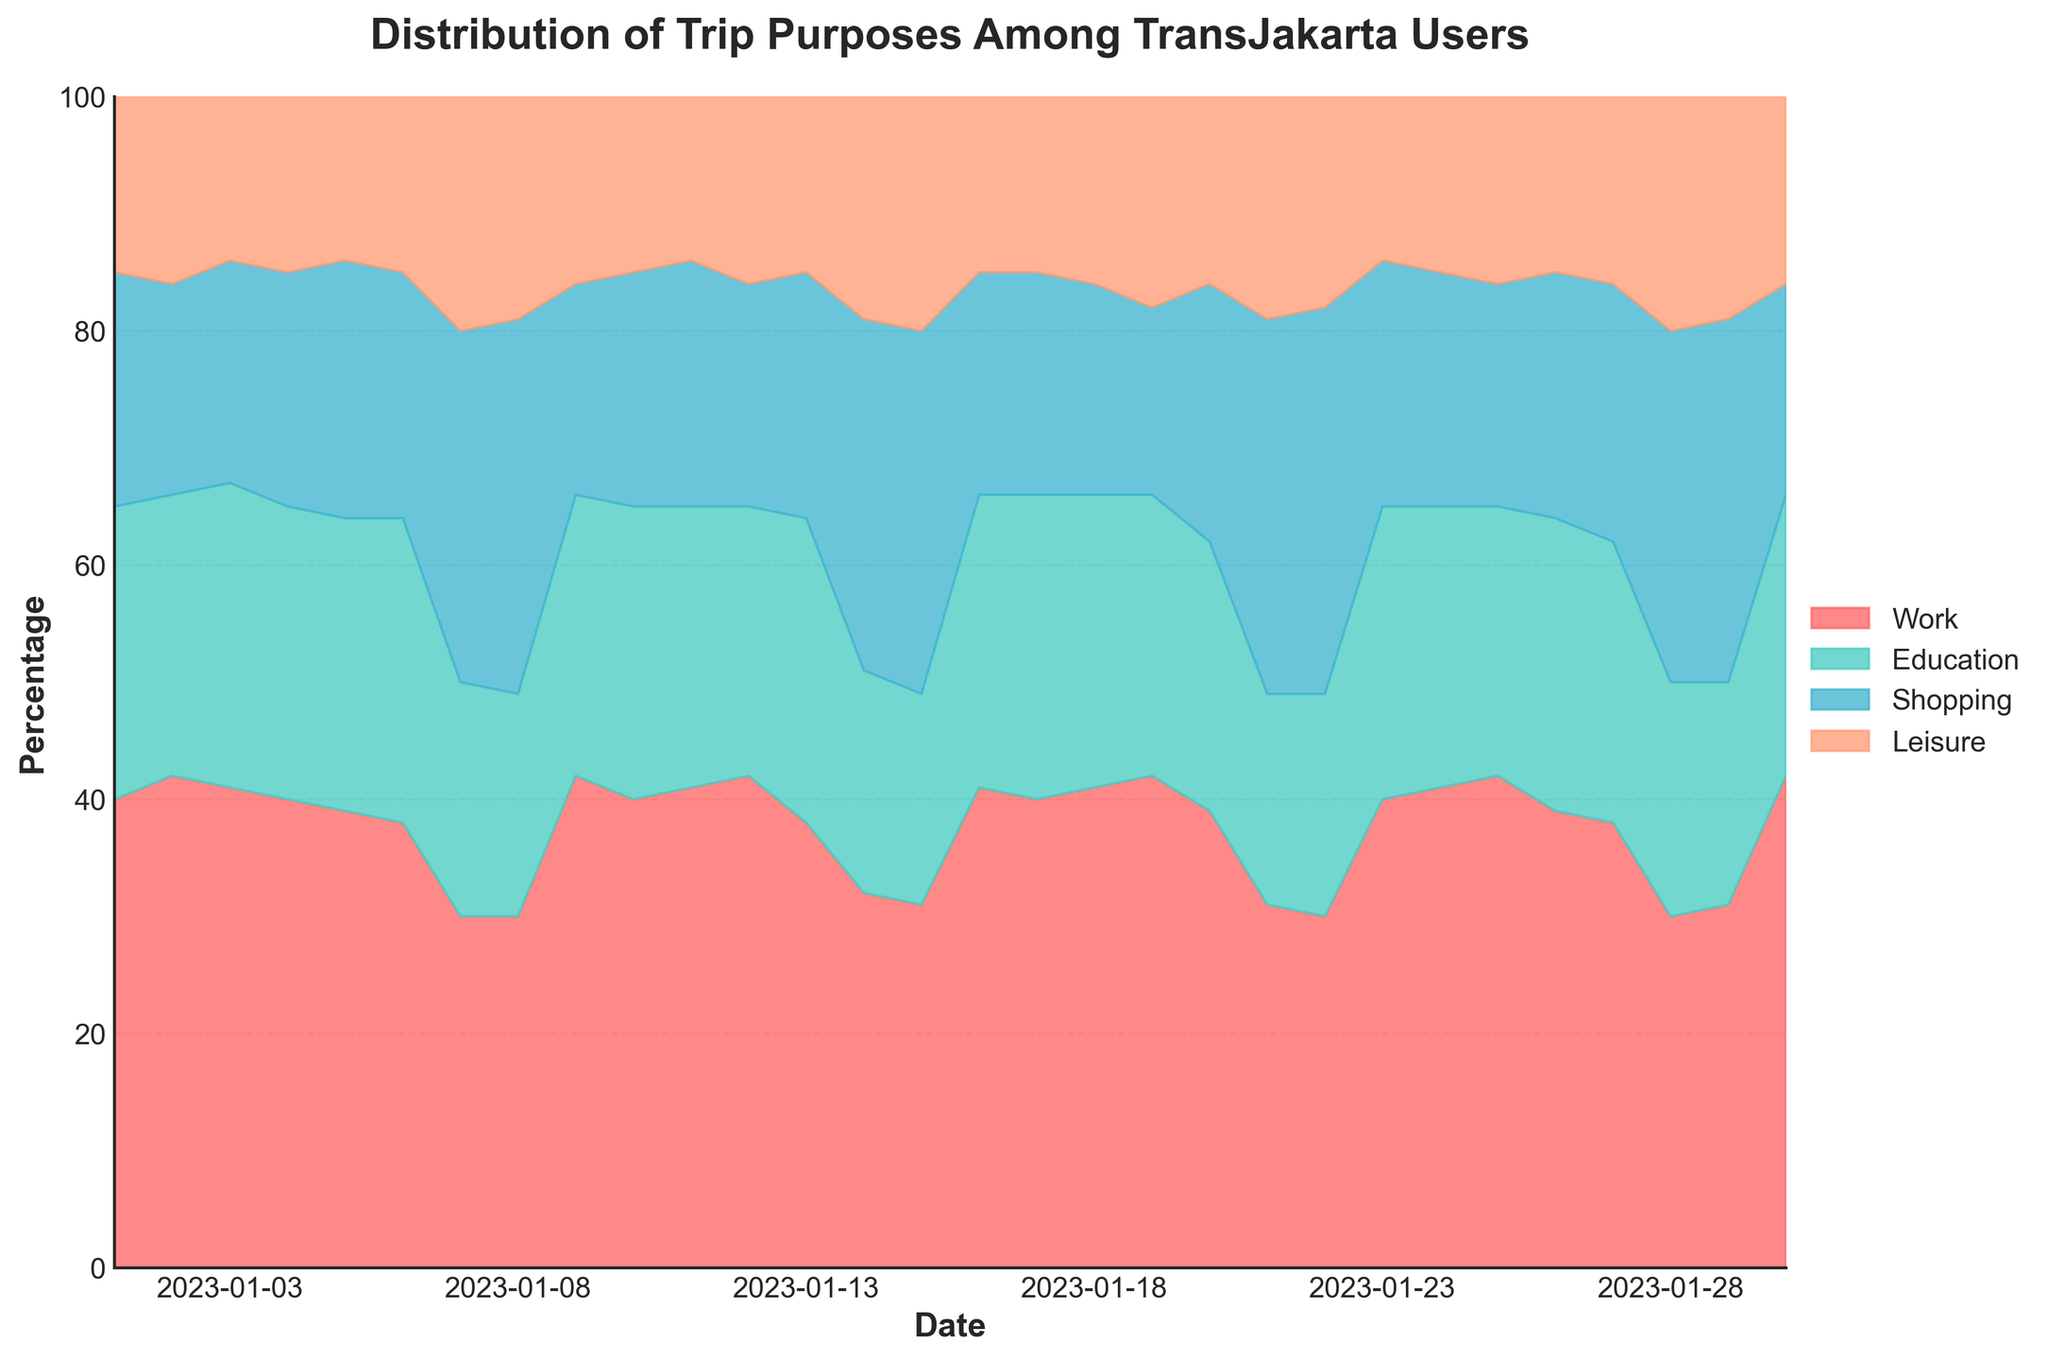What is the title of the chart? The title is displayed at the top of the chart. It indicates what the chart is about.
Answer: Distribution of Trip Purposes Among TransJakarta Users What are the four categories of trip purposes shown in the chart? By examining the legend on the right-hand side of the chart, we can see the labels for the trip purposes.
Answer: Work, Education, Shopping, Leisure Which category has the highest percentage on January 7, 2023? By looking at the stacked areas on the chart for January 7, 2023, we can see that the topmost section is the largest area, which corresponds to Shopping.
Answer: Shopping How does the percentage of trips for Education change from January 1, 2023, to January 30, 2023? By observing the light blue section labeled Education, we can see how its height changes from January 1 to January 30. The trend generally stays consistent with minor fluctuations.
Answer: Remains relatively stable What is the total percentage of trips for Work and Education on January 5, 2023? From the figure on January 5, 2023, we can see the stack heights for Work and Education. Adding them gives 39% + 25%.
Answer: 64% Which days show a noticeable increase in shopping trips? By observing the orange section, days like January 7 and January 8 show a larger area for Shopping.
Answer: January 7, January 8, January 14, January 15 What is the trend of leisure trips over January, and which date has the highest percentage for leisure? By following the light orange section labeled Leisure across the month, we can identify patterns and peaks, noting that peak leisure is seen on dates like January 7 and January 14.
Answer: Slight increase on weekends, highest on January 7 and 14 How does the distribution of trip purposes change during weekends compared to weekdays? By comparing the patterns on weekends (e.g., January 7, 8) versus weekdays, we see leisure and shopping percentages are higher on weekends.
Answer: Higher for leisure and shopping on weekends Which category remained the most stable throughout the timeframe? By examining the chart, we see that the height of the red section (Work) does not fluctuate much compared to others.
Answer: Work What is the difference in the percentage for Education trips between January 1, and January 30, 2023? By comparing the height of the light blue section for Education on January 1 and January 30, we note the percentages.
Answer: Same (25% on both days) 